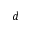Convert formula to latex. <formula><loc_0><loc_0><loc_500><loc_500>d</formula> 